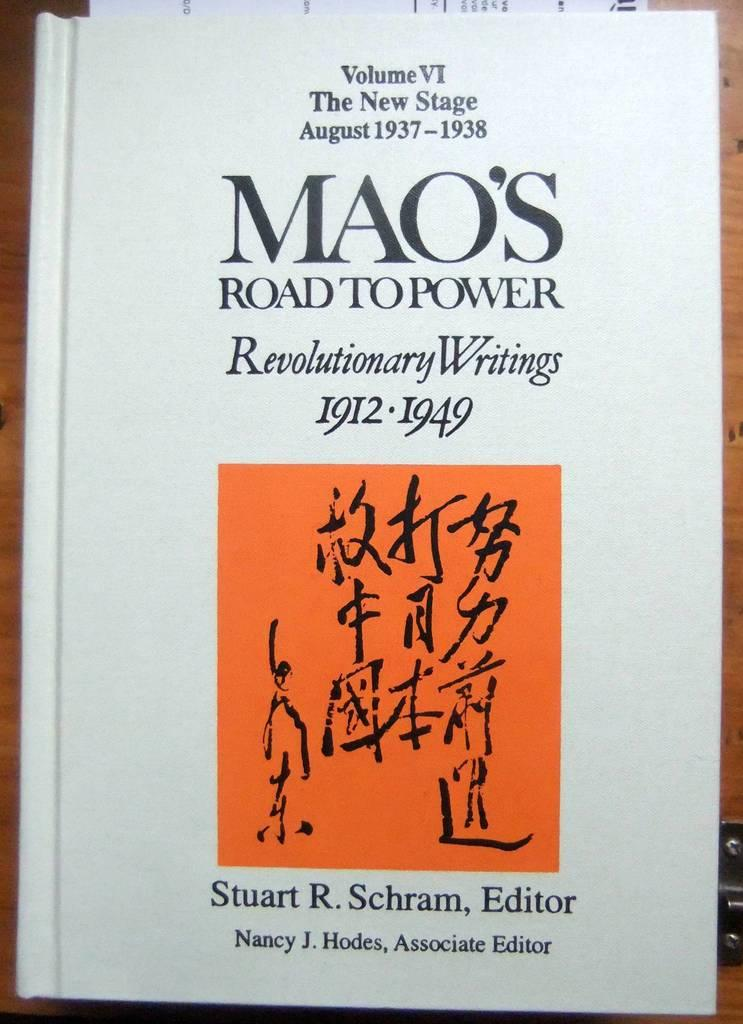<image>
Render a clear and concise summary of the photo. The cover of the book Mao's Road to Power, Revolutionary Writings 1912-1949. 